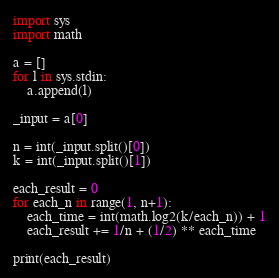<code> <loc_0><loc_0><loc_500><loc_500><_Python_>import sys
import math

a = []
for l in sys.stdin:
    a.append(l)

_input = a[0]

n = int(_input.split()[0])
k = int(_input.split()[1])

each_result = 0
for each_n in range(1, n+1):
    each_time = int(math.log2(k/each_n)) + 1
    each_result += 1/n + (1/2) ** each_time

print(each_result)
</code> 